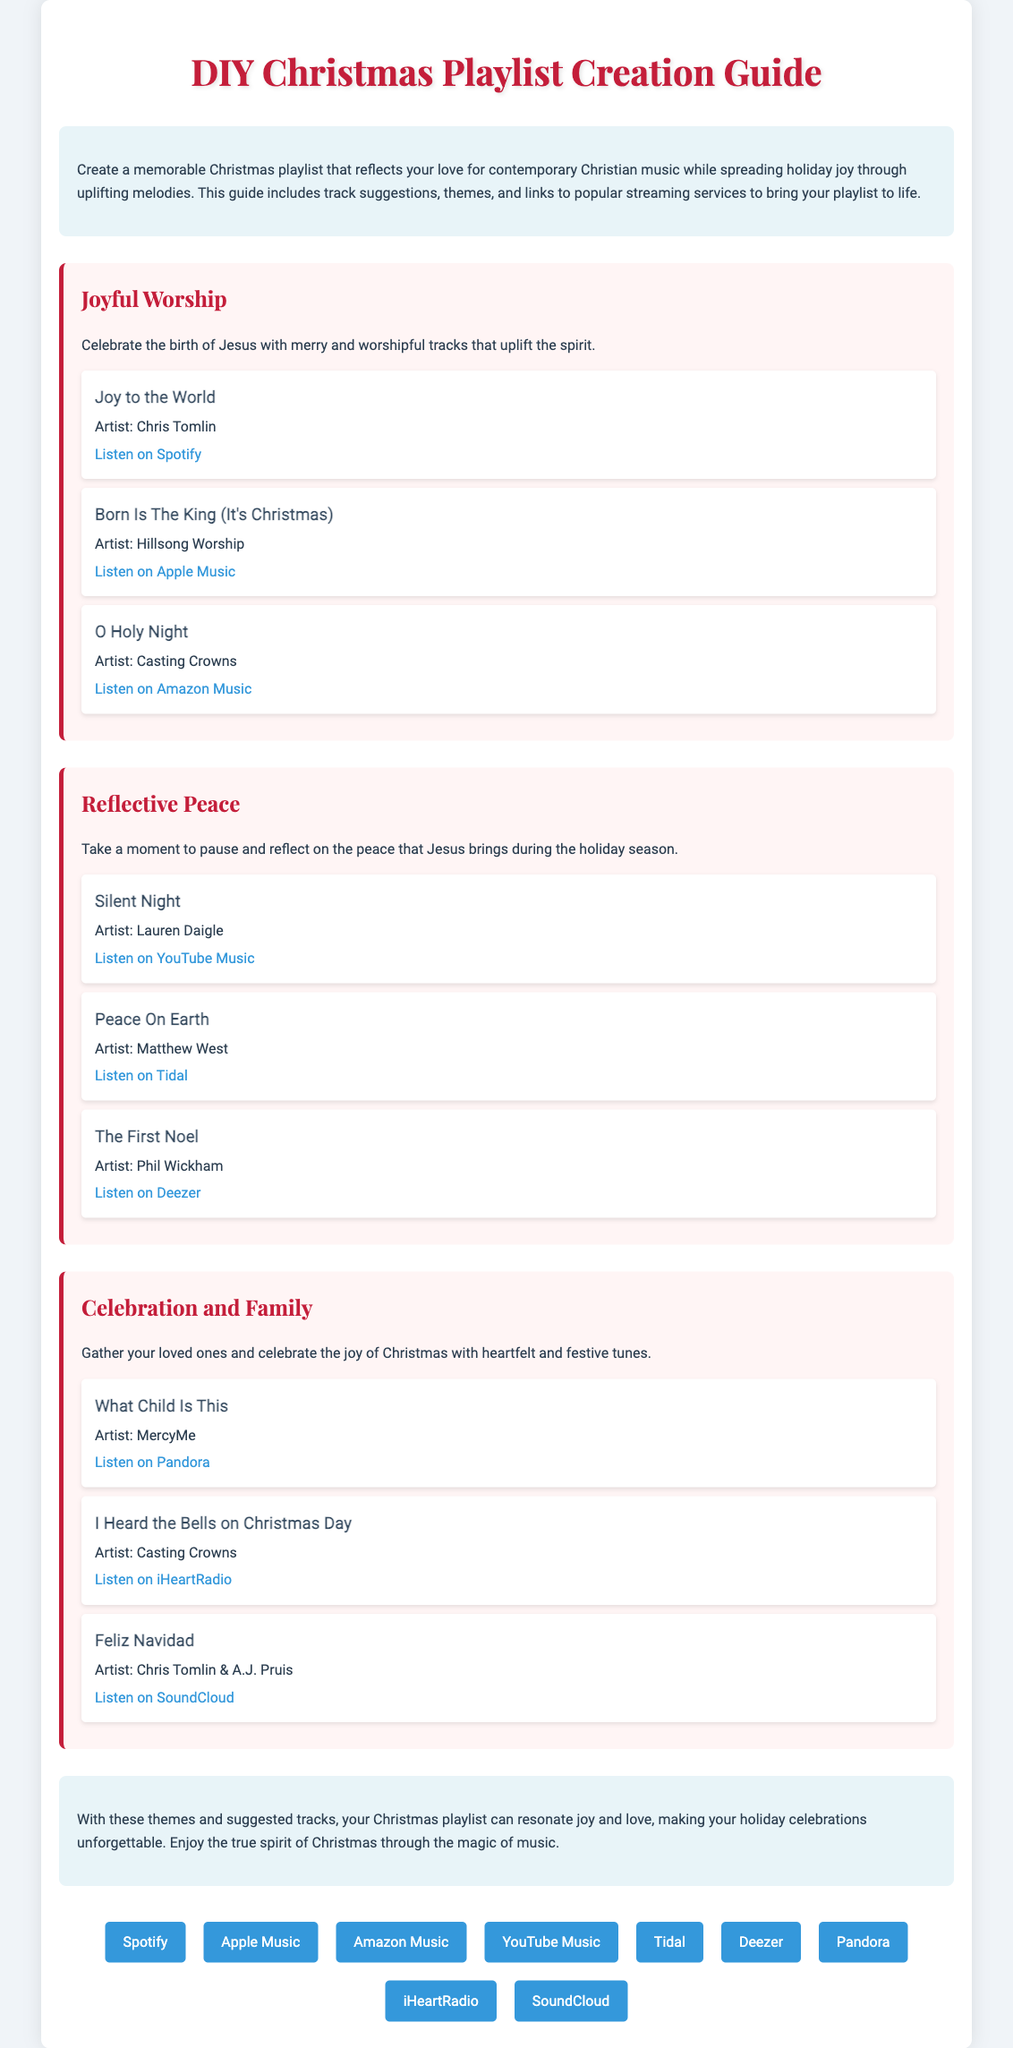What is the title of the guide? The title of the guide is provided at the beginning of the document.
Answer: DIY Christmas Playlist Creation Guide Who is the artist of "Joy to the World"? The artist for the track "Joy to the World" is mentioned in the document under the "Joyful Worship" theme.
Answer: Chris Tomlin Identify one track listed under the "Reflective Peace" theme. The document includes several tracks under the "Reflective Peace" theme, summarizing the information provided.
Answer: Silent Night What streaming service link is provided for "Born Is The King (It's Christmas)"? The track link is specified in the track details under the corresponding theme.
Answer: Listen on Apple Music How many tracks are suggested in the "Celebration and Family" theme? The number of tracks for each theme is outlined clearly in the document.
Answer: 3 What is the main focus of the guide? The guide's main focus entails crafting a Christmas playlist enriched with contemporary Christian music.
Answer: Christmas playlist creation Name one streaming service mentioned in the document. The document lists several streaming services for music listening, and one of them is highlighted as an example.
Answer: Spotify Which artist performed "O Holy Night"? The artist for the track specifically mentioned with the title "O Holy Night" can be found in the provided information.
Answer: Casting Crowns 